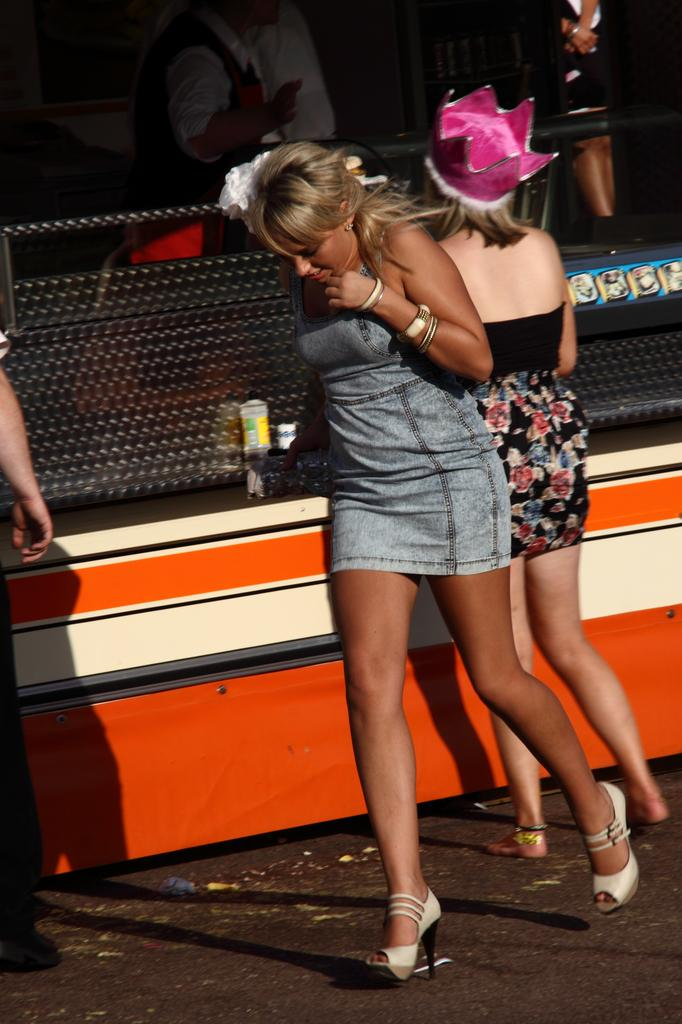What are the persons in the image doing? The persons in the image are walking. On what surface are the persons walking? The persons are walking on the ground. What object can be seen in the image that resembles a box? There is an object in the image that looks like a box. How many chairs can be seen in the image? There are no chairs present in the image. What color are the toes of the persons walking in the image? There is no information about the color of the persons' toes in the image. 